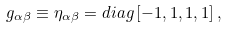Convert formula to latex. <formula><loc_0><loc_0><loc_500><loc_500>g _ { \alpha \beta } \equiv \eta _ { \alpha \beta } = d i a g \left [ { - 1 , 1 , 1 , 1 } \right ] ,</formula> 